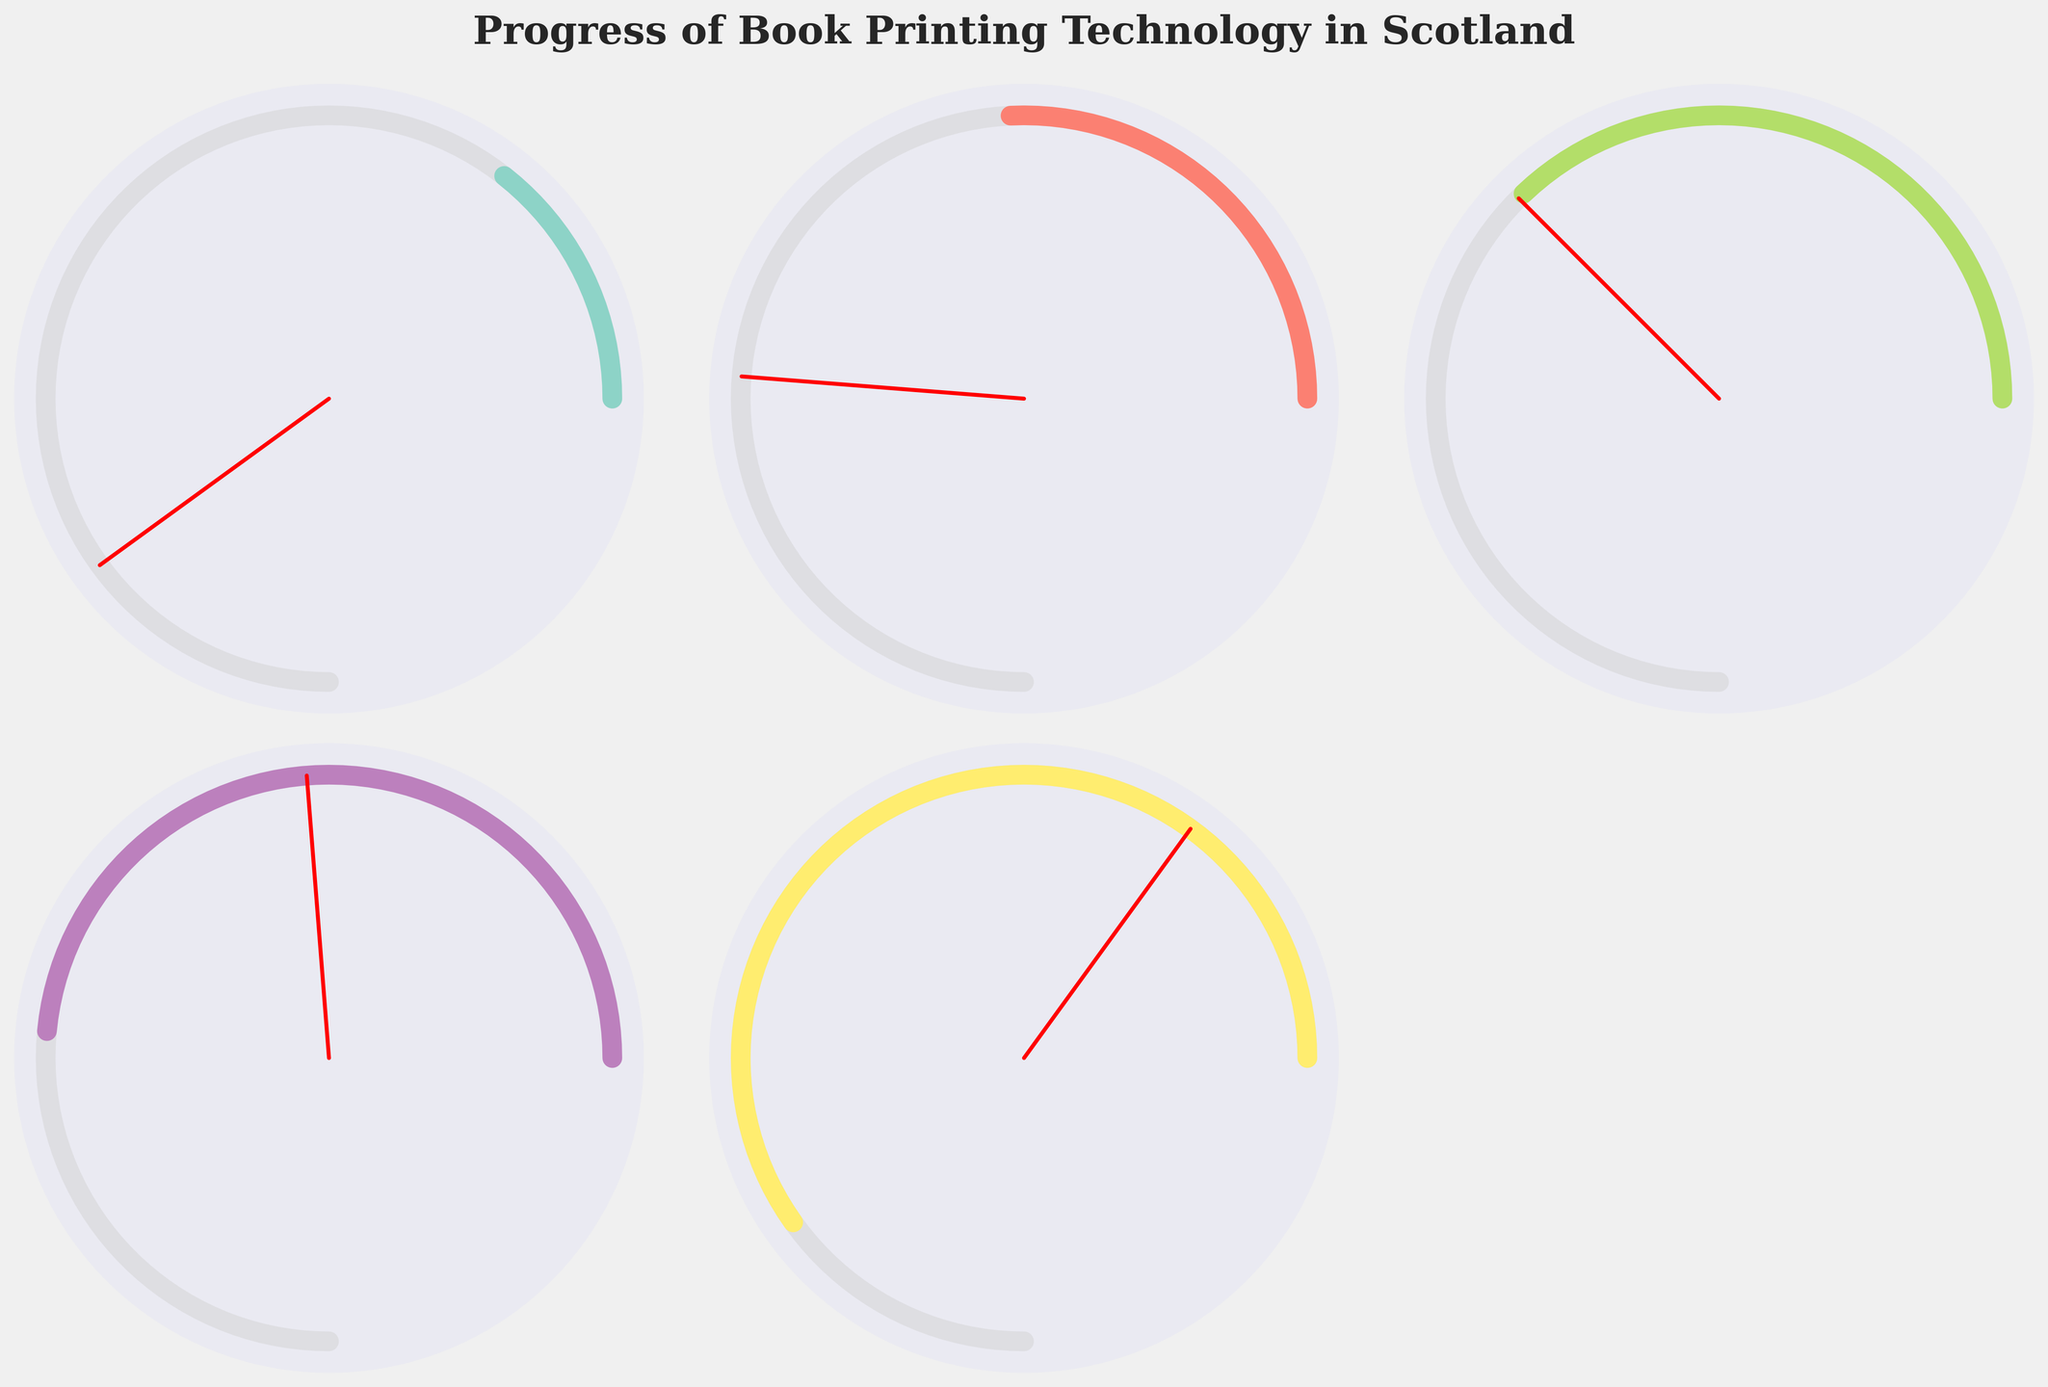What's the title of the figure? The title is located at the top of the figure, it's formatted in bold and serif font.
Answer: "Progress of Book Printing Technology in Scotland" How many subplots are present in the figure? The figure has a grid of subplots, specifically 2 rows and 3 columns. By counting the subplots, we find that there are 6 in total.
Answer: 6 Which year had the highest efficiency in book printing technology? Look for the gauge chart with the highest percentage. The subplot with "Edinburgh's Mechanized Press" in the year 1720 has an efficiency of 80%, which is the highest.
Answer: 1720 What is the percentage efficiency of the printing process in the year 1700? Locate the subplot for the year 1700. Its efficiency is indicated as 65%.
Answer: 65% Compare the efficiency of the book printing processes between 1600 and 1650. Look at the efficiency values in the subplots for the years 1600 and 1650. For 1600, it's 20%, and for 1650, it's 35%. The efficiency in 1650 is higher than in 1600 by 15%.
Answer: The efficiency in 1650 is 15% higher What's the average efficiency of the printing processes in the 17th century (1600-1700)? We need to average the efficiencies for the years 1600, 1650, 1680, and 1700. These are 20%, 35%, 50%, and 65%. Sum them up to get 170%, then divide by 4.
Answer: (20 + 35 + 50 + 65) / 4 = 42.5% Which process shows a 50% efficiency? Locate the process with the efficiency indicator showing 50%. The subplot labeled "Early Semi-Automated Press" for the year 1680 has 50% efficiency.
Answer: Early Semi-Automated Press Does the efficiency of printing technology show a generally increasing trend from 1600 to 1720? Compare the efficiency values from 1600 (20%), 1650 (35%), 1680 (50%), 1700 (65%), to 1720 (80%). The values show a consistent increase over time.
Answer: Yes, it increases What is the difference in efficiency between the Improved Manual Letterpress and the Advanced Semi-Automated Press? Look at the efficiency values for 1650 (Improved Manual Letterpress, 35%) and 1700 (Advanced Semi-Automated Press, 65%). Subtract 35% from 65%.
Answer: 65% - 35% = 30% Is there any process with an efficiency below 30%? Check the efficiency percentage for each process. Only the process in 1600 (Manual Letterpress) has an efficiency of 20%, which is below 30%.
Answer: Yes, the Manual Letterpress 